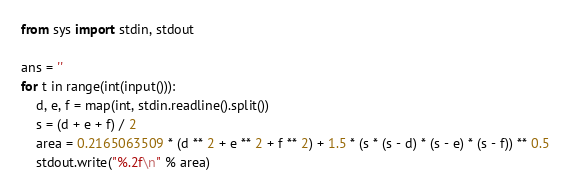Convert code to text. <code><loc_0><loc_0><loc_500><loc_500><_Python_>from sys import stdin, stdout

ans = ''
for t in range(int(input())):
    d, e, f = map(int, stdin.readline().split())
    s = (d + e + f) / 2
    area = 0.2165063509 * (d ** 2 + e ** 2 + f ** 2) + 1.5 * (s * (s - d) * (s - e) * (s - f)) ** 0.5
    stdout.write("%.2f\n" % area)
</code> 